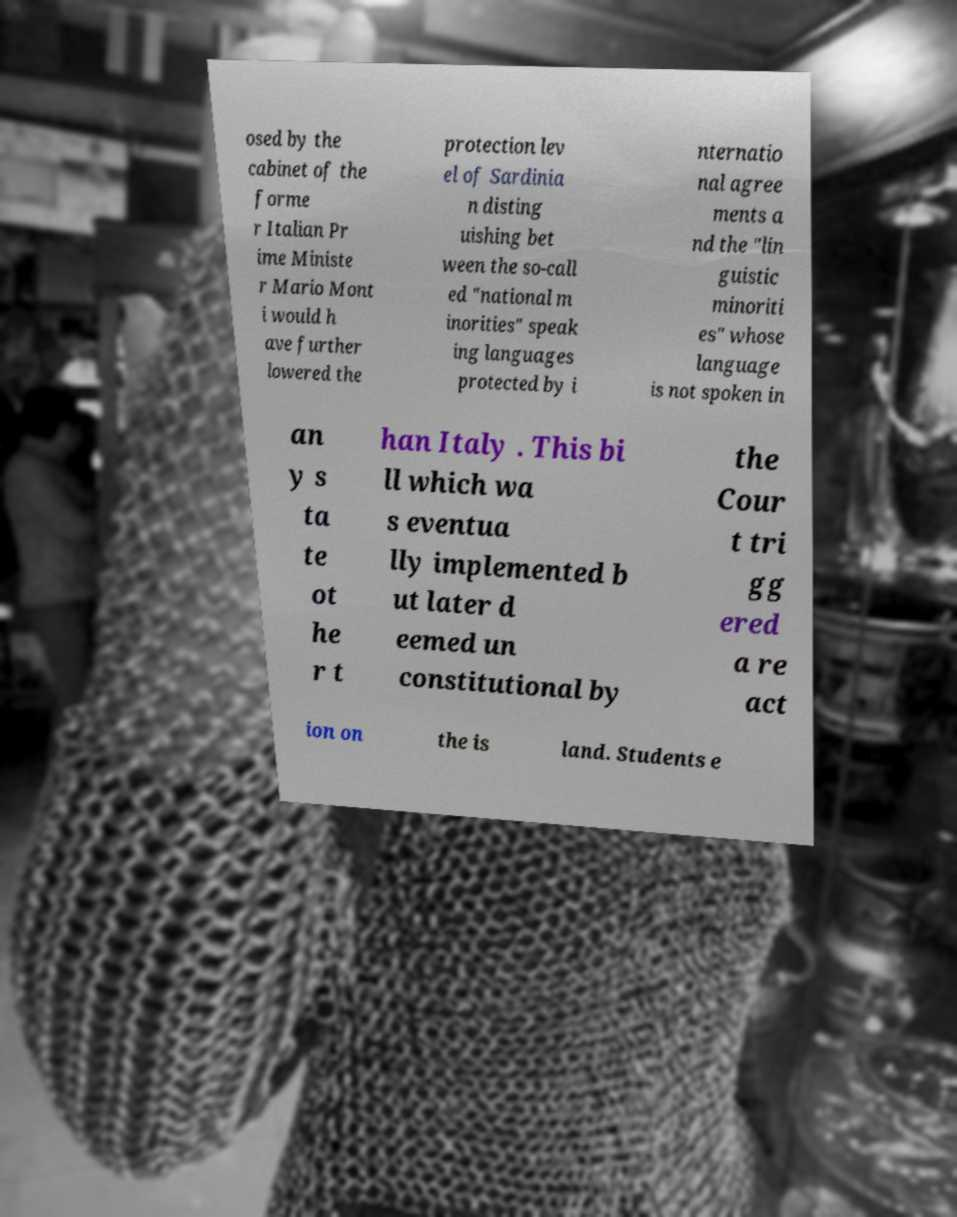Please read and relay the text visible in this image. What does it say? osed by the cabinet of the forme r Italian Pr ime Ministe r Mario Mont i would h ave further lowered the protection lev el of Sardinia n disting uishing bet ween the so-call ed "national m inorities" speak ing languages protected by i nternatio nal agree ments a nd the "lin guistic minoriti es" whose language is not spoken in an y s ta te ot he r t han Italy . This bi ll which wa s eventua lly implemented b ut later d eemed un constitutional by the Cour t tri gg ered a re act ion on the is land. Students e 